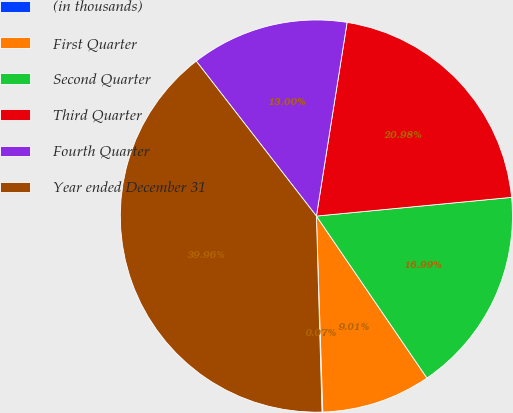Convert chart to OTSL. <chart><loc_0><loc_0><loc_500><loc_500><pie_chart><fcel>(in thousands)<fcel>First Quarter<fcel>Second Quarter<fcel>Third Quarter<fcel>Fourth Quarter<fcel>Year ended December 31<nl><fcel>0.07%<fcel>9.01%<fcel>16.99%<fcel>20.98%<fcel>13.0%<fcel>39.96%<nl></chart> 